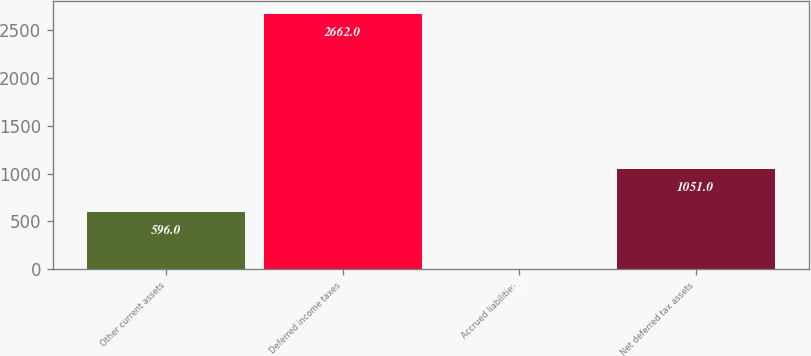Convert chart. <chart><loc_0><loc_0><loc_500><loc_500><bar_chart><fcel>Other current assets<fcel>Deferred income taxes<fcel>Accrued liabilities<fcel>Net deferred tax assets<nl><fcel>596<fcel>2662<fcel>9<fcel>1051<nl></chart> 